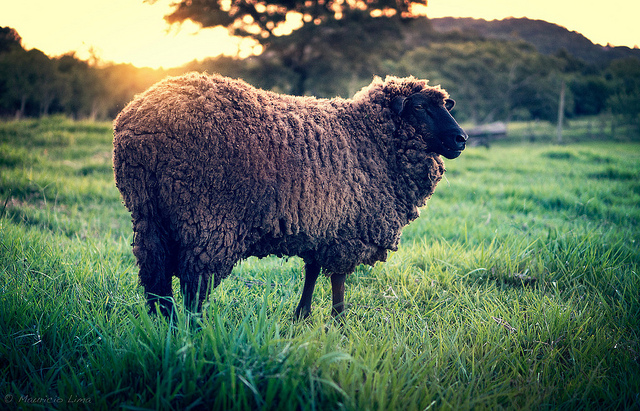Create a poem about the sheep and its environment. In the golden glow of dawn’s embrace,
Stands a sheep in a tranquil place.
With curly fleece of brown so deep,
In the meadow, it finds its keep.
Grass sways gently, tall and green,
In this serene and peaceful scene.
Hills and trees frame the view,
Under skies of morning’s hue.
In quiet fields where shadows play,
The sheep will graze and gently sway.
For in this space, so wide and free,
It finds peace and harmony. 